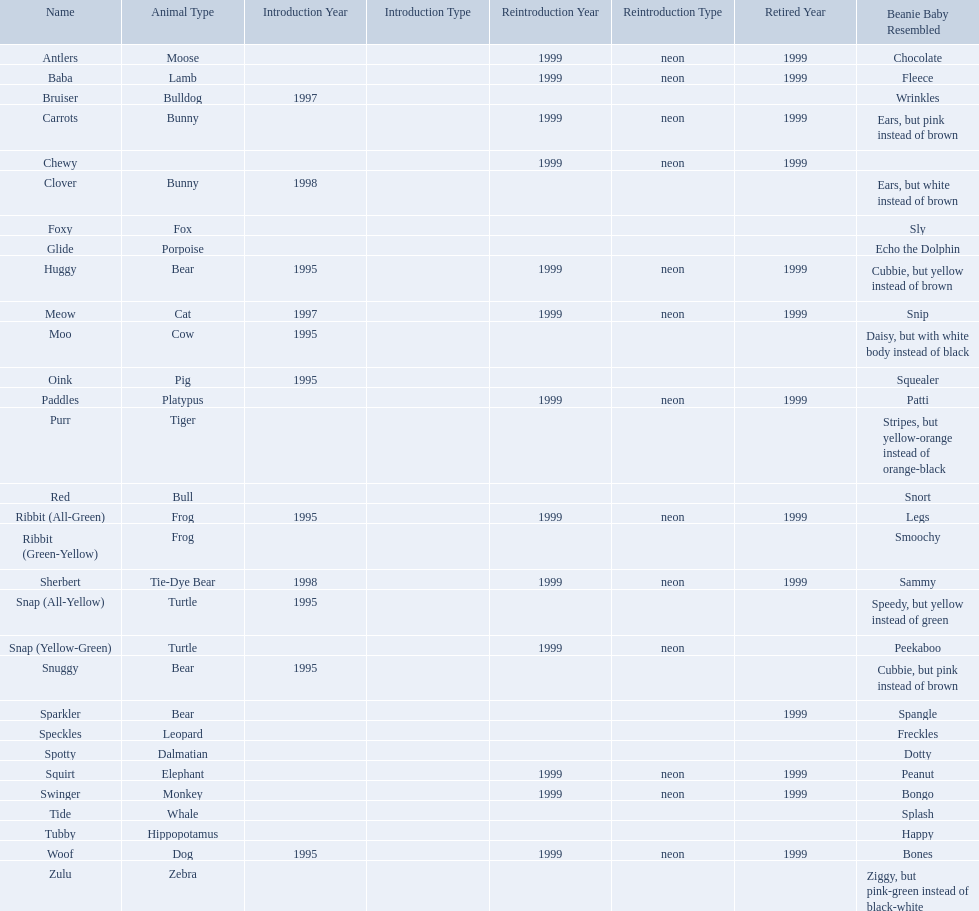Which of the listed pillow pals lack information in at least 3 categories? Chewy, Foxy, Glide, Purr, Red, Ribbit (Green-Yellow), Speckles, Spotty, Tide, Tubby, Zulu. Of those, which one lacks information in the animal type category? Chewy. What are the names listed? Antlers, Baba, Bruiser, Carrots, Chewy, Clover, Foxy, Glide, Huggy, Meow, Moo, Oink, Paddles, Purr, Red, Ribbit (All-Green), Ribbit (Green-Yellow), Sherbert, Snap (All-Yellow), Snap (Yellow-Green), Snuggy, Sparkler, Speckles, Spotty, Squirt, Swinger, Tide, Tubby, Woof, Zulu. Of these, which is the only pet without an animal type listed? Chewy. 